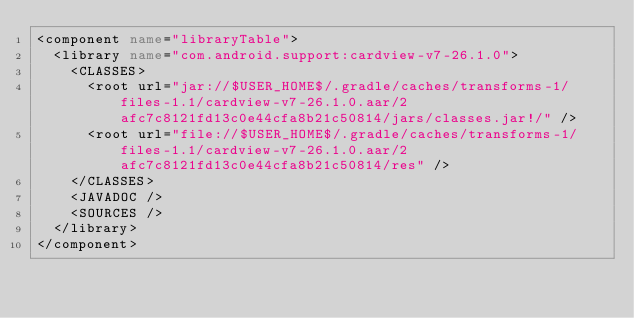Convert code to text. <code><loc_0><loc_0><loc_500><loc_500><_XML_><component name="libraryTable">
  <library name="com.android.support:cardview-v7-26.1.0">
    <CLASSES>
      <root url="jar://$USER_HOME$/.gradle/caches/transforms-1/files-1.1/cardview-v7-26.1.0.aar/2afc7c8121fd13c0e44cfa8b21c50814/jars/classes.jar!/" />
      <root url="file://$USER_HOME$/.gradle/caches/transforms-1/files-1.1/cardview-v7-26.1.0.aar/2afc7c8121fd13c0e44cfa8b21c50814/res" />
    </CLASSES>
    <JAVADOC />
    <SOURCES />
  </library>
</component></code> 